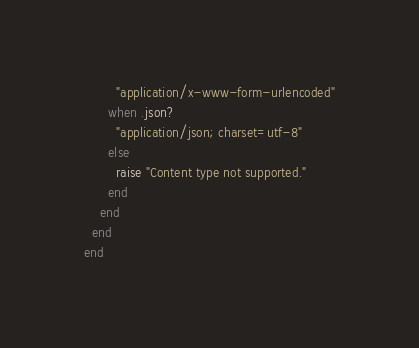Convert code to text. <code><loc_0><loc_0><loc_500><loc_500><_Crystal_>        "application/x-www-form-urlencoded"
      when .json?
        "application/json; charset=utf-8"
      else
        raise "Content type not supported."
      end
    end
  end
end
</code> 